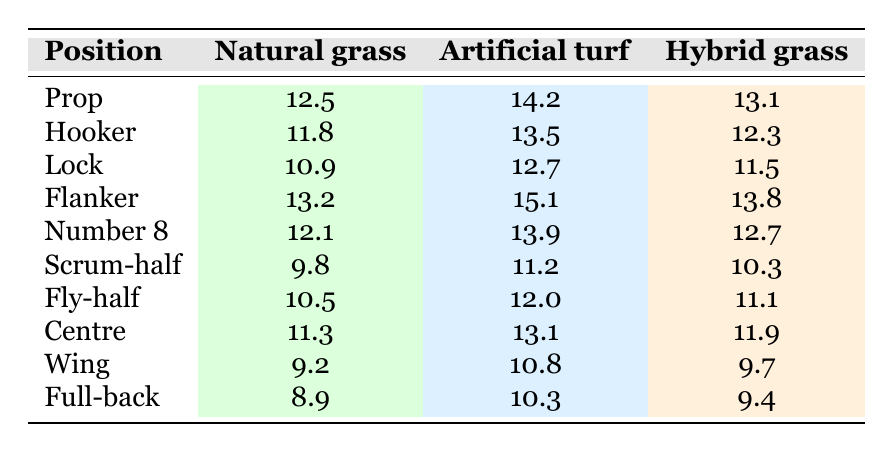What is the injury rate for Prop players on artificial turf? The injury rate for Prop players on artificial turf can be found directly in the table. It states that the injury rate for Props on this surface is 14.2.
Answer: 14.2 Which position has the highest injury rate on natural grass? The table lists the injury rates for each position on natural grass. Flanker has the highest rate at 13.2.
Answer: Flanker Is the injury rate for Full-backs on hybrid grass higher than that for Wing players on the same surface? The table shows that the injury rate for Full-backs on hybrid grass is 9.4, while the rate for Wing players is 9.7. Since 9.4 is less than 9.7, the statement is false.
Answer: No What is the average injury rate for all positions on artificial turf? To find the average, first sum the injury rates on artificial turf: 14.2 + 13.5 + 12.7 + 15.1 + 13.9 + 11.2 + 12.0 + 13.1 + 10.8 + 10.3 = 133.8. There are 10 positions, so the average is 133.8 / 10 = 13.38.
Answer: 13.38 Does the injury rate for Scrum-half players on natural grass exceed the overall average of 12? The injury rate for Scrum-half players on natural grass is 9.8. This is less than the overall average of 12, so the statement is false.
Answer: No What is the difference in injury rates between Flankers on artificial turf and Locks on the same surface? Flankers have an injury rate of 15.1 on artificial turf, while Locks have a rate of 12.7. The difference is calculated as 15.1 - 12.7 = 2.4.
Answer: 2.4 Which position has the lowest injury rate on natural grass? Referring to the table, Full-back has the lowest injury rate on natural grass at 8.9.
Answer: Full-back Are injury rates generally higher on artificial turf compared to natural grass for all positions? By examining the table, it shows that for every position listed, the injury rates on artificial turf are higher than those on natural grass. Therefore, the statement is true.
Answer: Yes 